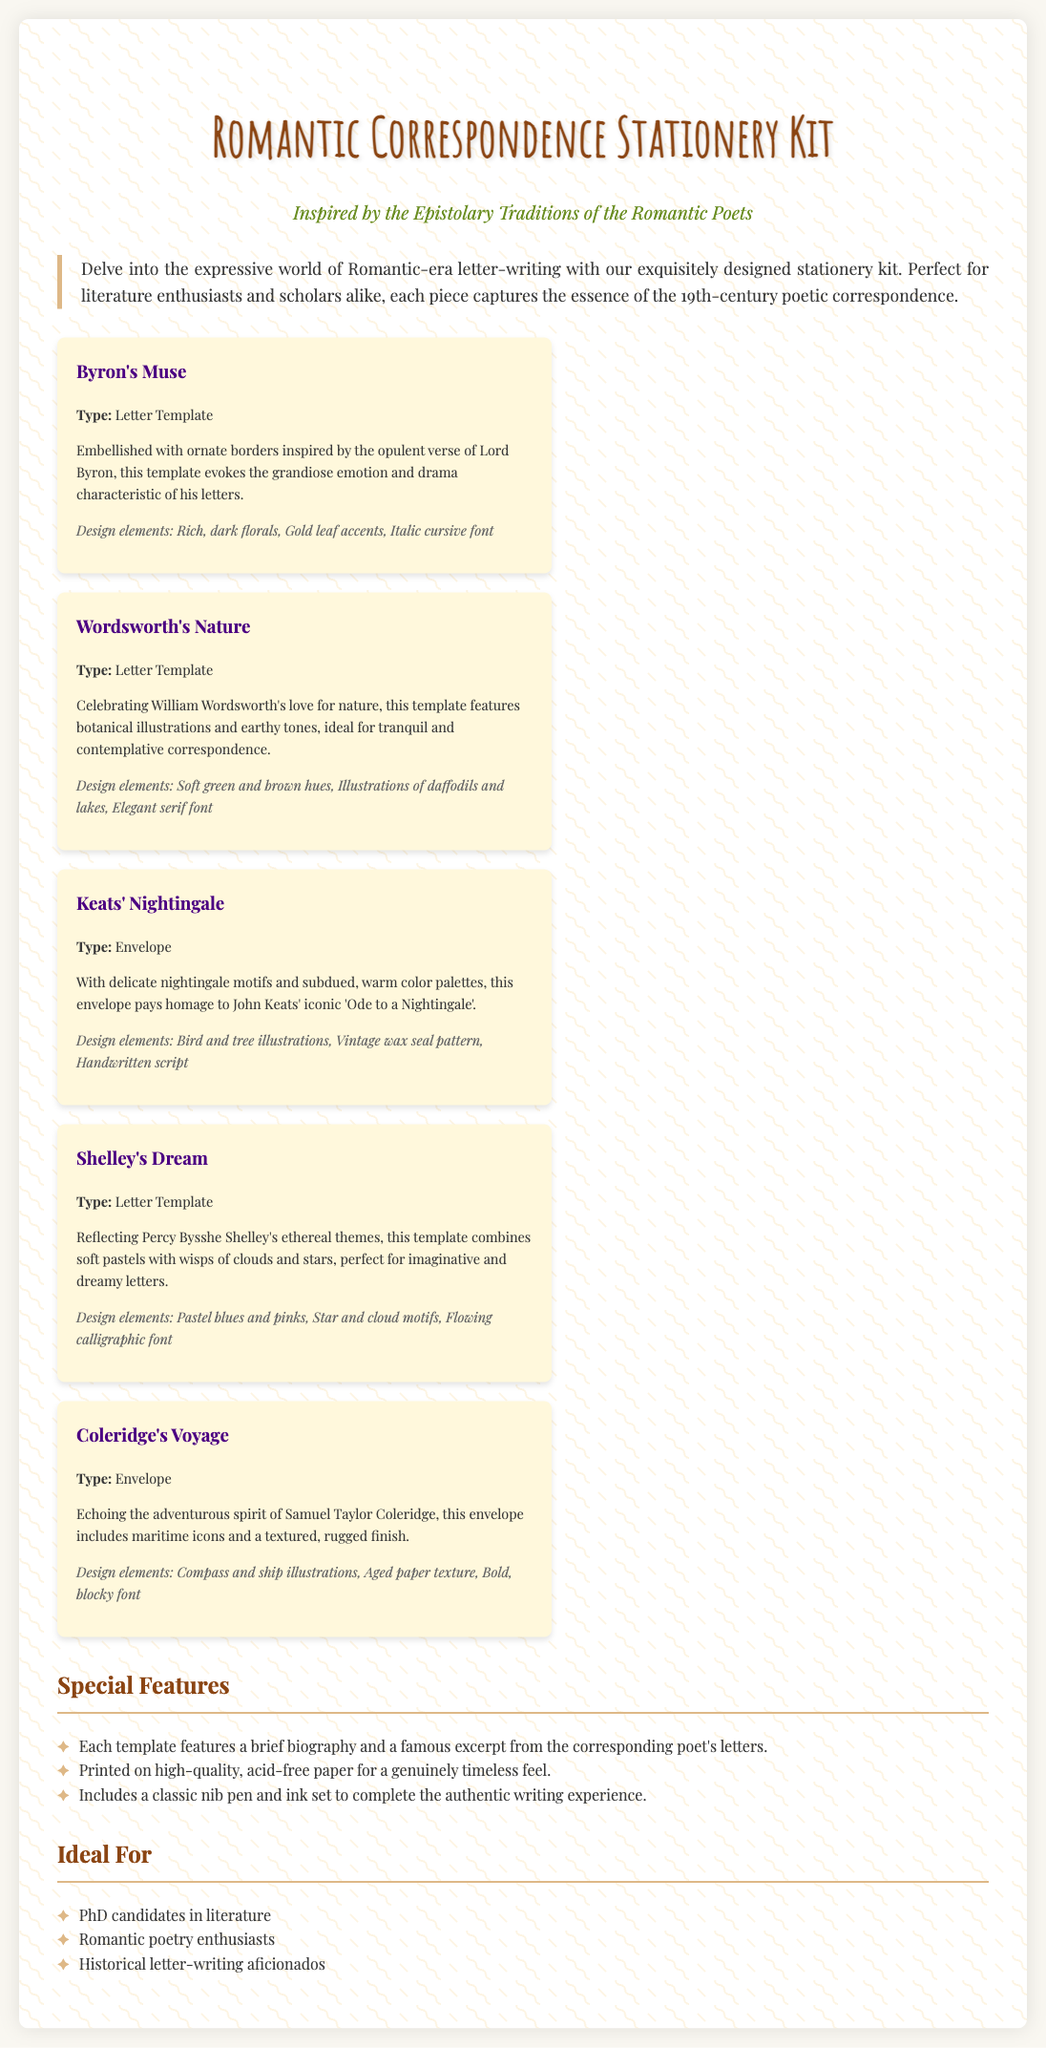What is the title of the product? The title of the product is prominently displayed at the top of the document.
Answer: Romantic Correspondence Stationery Kit Who is the poet associated with the "Nightingale" envelope? The envelope named "Nightingale" is associated with John Keats based on his correspondence.
Answer: John Keats What type of decorative elements are on Byron's letter template? The specific design elements for Byron's template include ornate borders inspired by his verse.
Answer: Rich, dark florals, Gold leaf accents, Italic cursive font How many letter templates are included in the kit? The document lists four items categorized as letter templates among the products.
Answer: Four What is a unique feature of each template? Each template includes extra information connecting it to the corresponding poet's works.
Answer: A brief biography and a famous excerpt Which audience is indicated as "Ideal For"? The section lists specific groups who may find the product appealing.
Answer: PhD candidates in literature What colors are used in Shelley's Dream letter template? The document describes the soft colors used in Shelley's template.
Answer: Pastel blues and pinks What quality does the stationery paper possess? The document indicates the quality type of the paper used for printing.
Answer: Acid-free paper 